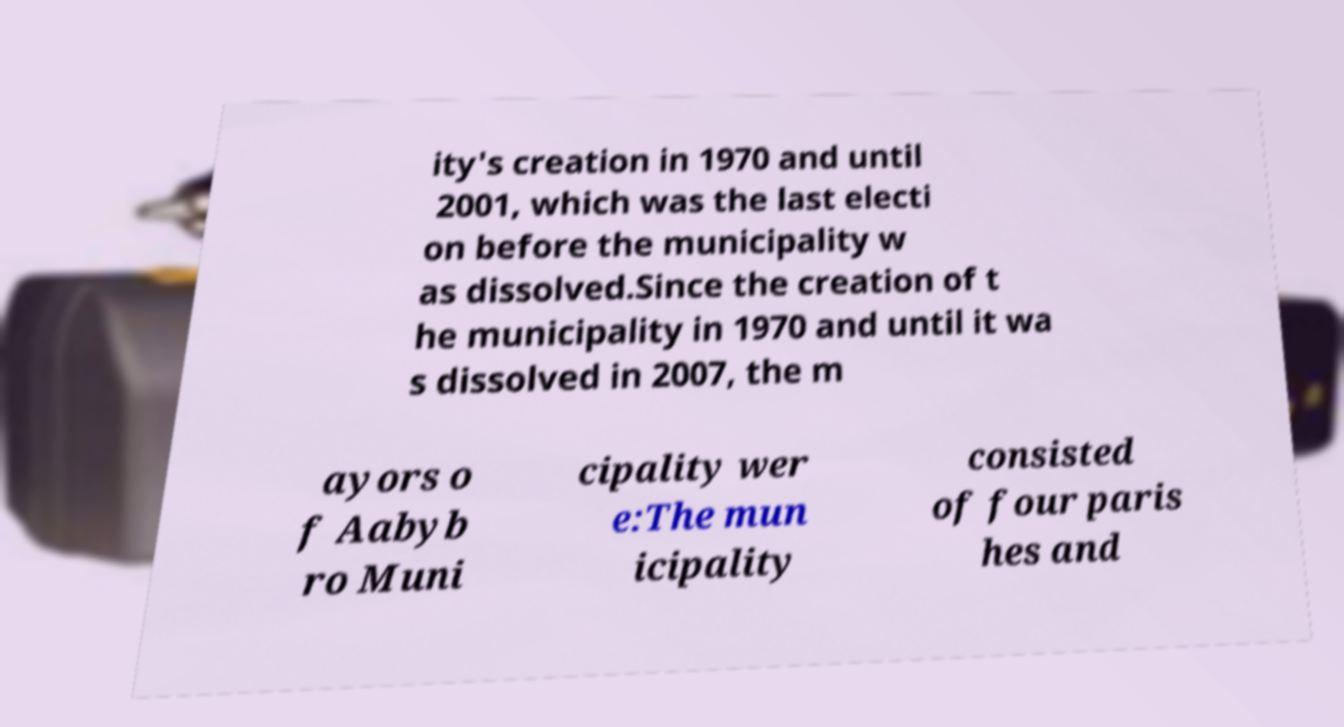For documentation purposes, I need the text within this image transcribed. Could you provide that? ity's creation in 1970 and until 2001, which was the last electi on before the municipality w as dissolved.Since the creation of t he municipality in 1970 and until it wa s dissolved in 2007, the m ayors o f Aabyb ro Muni cipality wer e:The mun icipality consisted of four paris hes and 